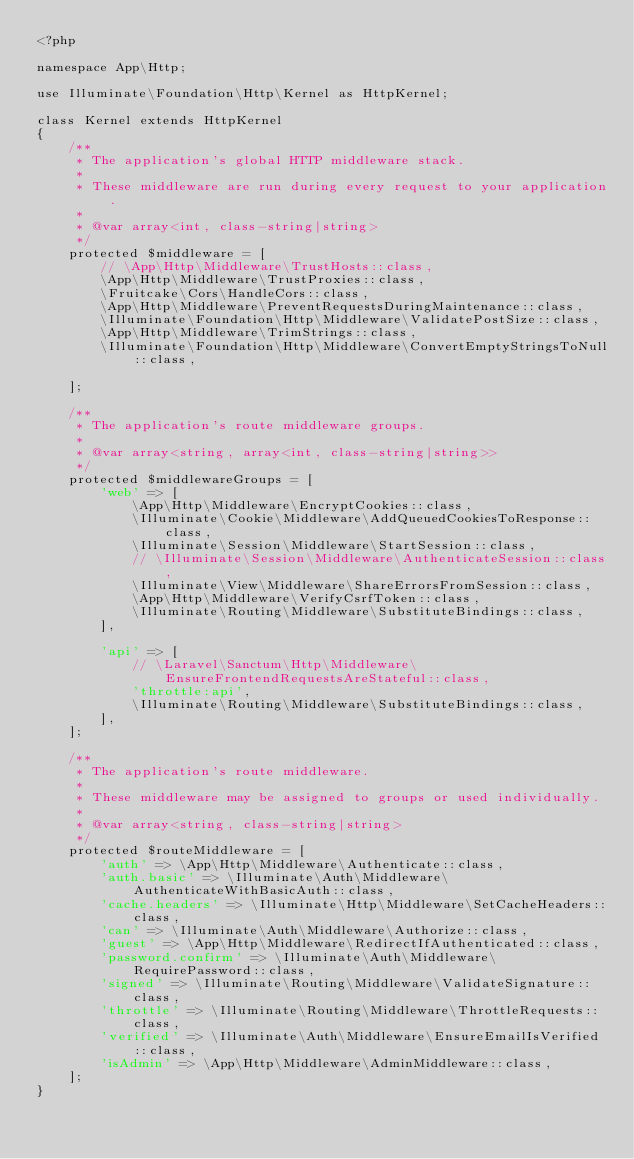Convert code to text. <code><loc_0><loc_0><loc_500><loc_500><_PHP_><?php

namespace App\Http;

use Illuminate\Foundation\Http\Kernel as HttpKernel;

class Kernel extends HttpKernel
{
    /**
     * The application's global HTTP middleware stack.
     *
     * These middleware are run during every request to your application.
     *
     * @var array<int, class-string|string>
     */
    protected $middleware = [
        // \App\Http\Middleware\TrustHosts::class,
        \App\Http\Middleware\TrustProxies::class,
        \Fruitcake\Cors\HandleCors::class,
        \App\Http\Middleware\PreventRequestsDuringMaintenance::class,
        \Illuminate\Foundation\Http\Middleware\ValidatePostSize::class,
        \App\Http\Middleware\TrimStrings::class,
        \Illuminate\Foundation\Http\Middleware\ConvertEmptyStringsToNull::class,

    ];

    /**
     * The application's route middleware groups.
     *
     * @var array<string, array<int, class-string|string>>
     */
    protected $middlewareGroups = [
        'web' => [
            \App\Http\Middleware\EncryptCookies::class,
            \Illuminate\Cookie\Middleware\AddQueuedCookiesToResponse::class,
            \Illuminate\Session\Middleware\StartSession::class,
            // \Illuminate\Session\Middleware\AuthenticateSession::class,
            \Illuminate\View\Middleware\ShareErrorsFromSession::class,
            \App\Http\Middleware\VerifyCsrfToken::class,
            \Illuminate\Routing\Middleware\SubstituteBindings::class,
        ],

        'api' => [
            // \Laravel\Sanctum\Http\Middleware\EnsureFrontendRequestsAreStateful::class,
            'throttle:api',
            \Illuminate\Routing\Middleware\SubstituteBindings::class,
        ],
    ];

    /**
     * The application's route middleware.
     *
     * These middleware may be assigned to groups or used individually.
     *
     * @var array<string, class-string|string>
     */
    protected $routeMiddleware = [
        'auth' => \App\Http\Middleware\Authenticate::class,
        'auth.basic' => \Illuminate\Auth\Middleware\AuthenticateWithBasicAuth::class,
        'cache.headers' => \Illuminate\Http\Middleware\SetCacheHeaders::class,
        'can' => \Illuminate\Auth\Middleware\Authorize::class,
        'guest' => \App\Http\Middleware\RedirectIfAuthenticated::class,
        'password.confirm' => \Illuminate\Auth\Middleware\RequirePassword::class,
        'signed' => \Illuminate\Routing\Middleware\ValidateSignature::class,
        'throttle' => \Illuminate\Routing\Middleware\ThrottleRequests::class,
        'verified' => \Illuminate\Auth\Middleware\EnsureEmailIsVerified::class,
        'isAdmin' => \App\Http\Middleware\AdminMiddleware::class,
    ];
}
</code> 